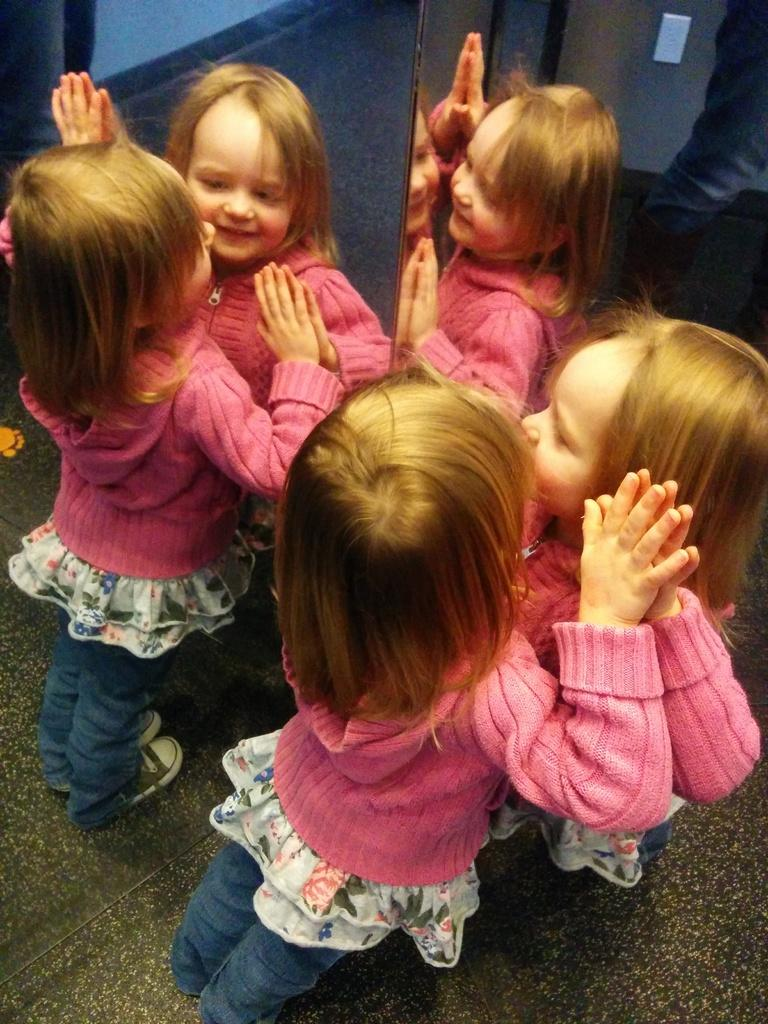What is the main subject of the image? There is a child in the image. Can you describe the child's clothing? The child is wearing a dress with pink, white, and blue colors. What is the child's posture in the image? The child is standing. What objects are present in the image that might be used for self-reflection? There are mirrors in the image. What can be seen in the mirrors in the image? The reflections of the child are visible in the mirrors. What type of leather material is used to make the child's dress in the image? There is no mention of leather in the description of the child's dress; it is described as having pink, white, and blue colors. Is there a partner visible in the image with the child? There is no mention of a partner or any other person in the image besides the child. 